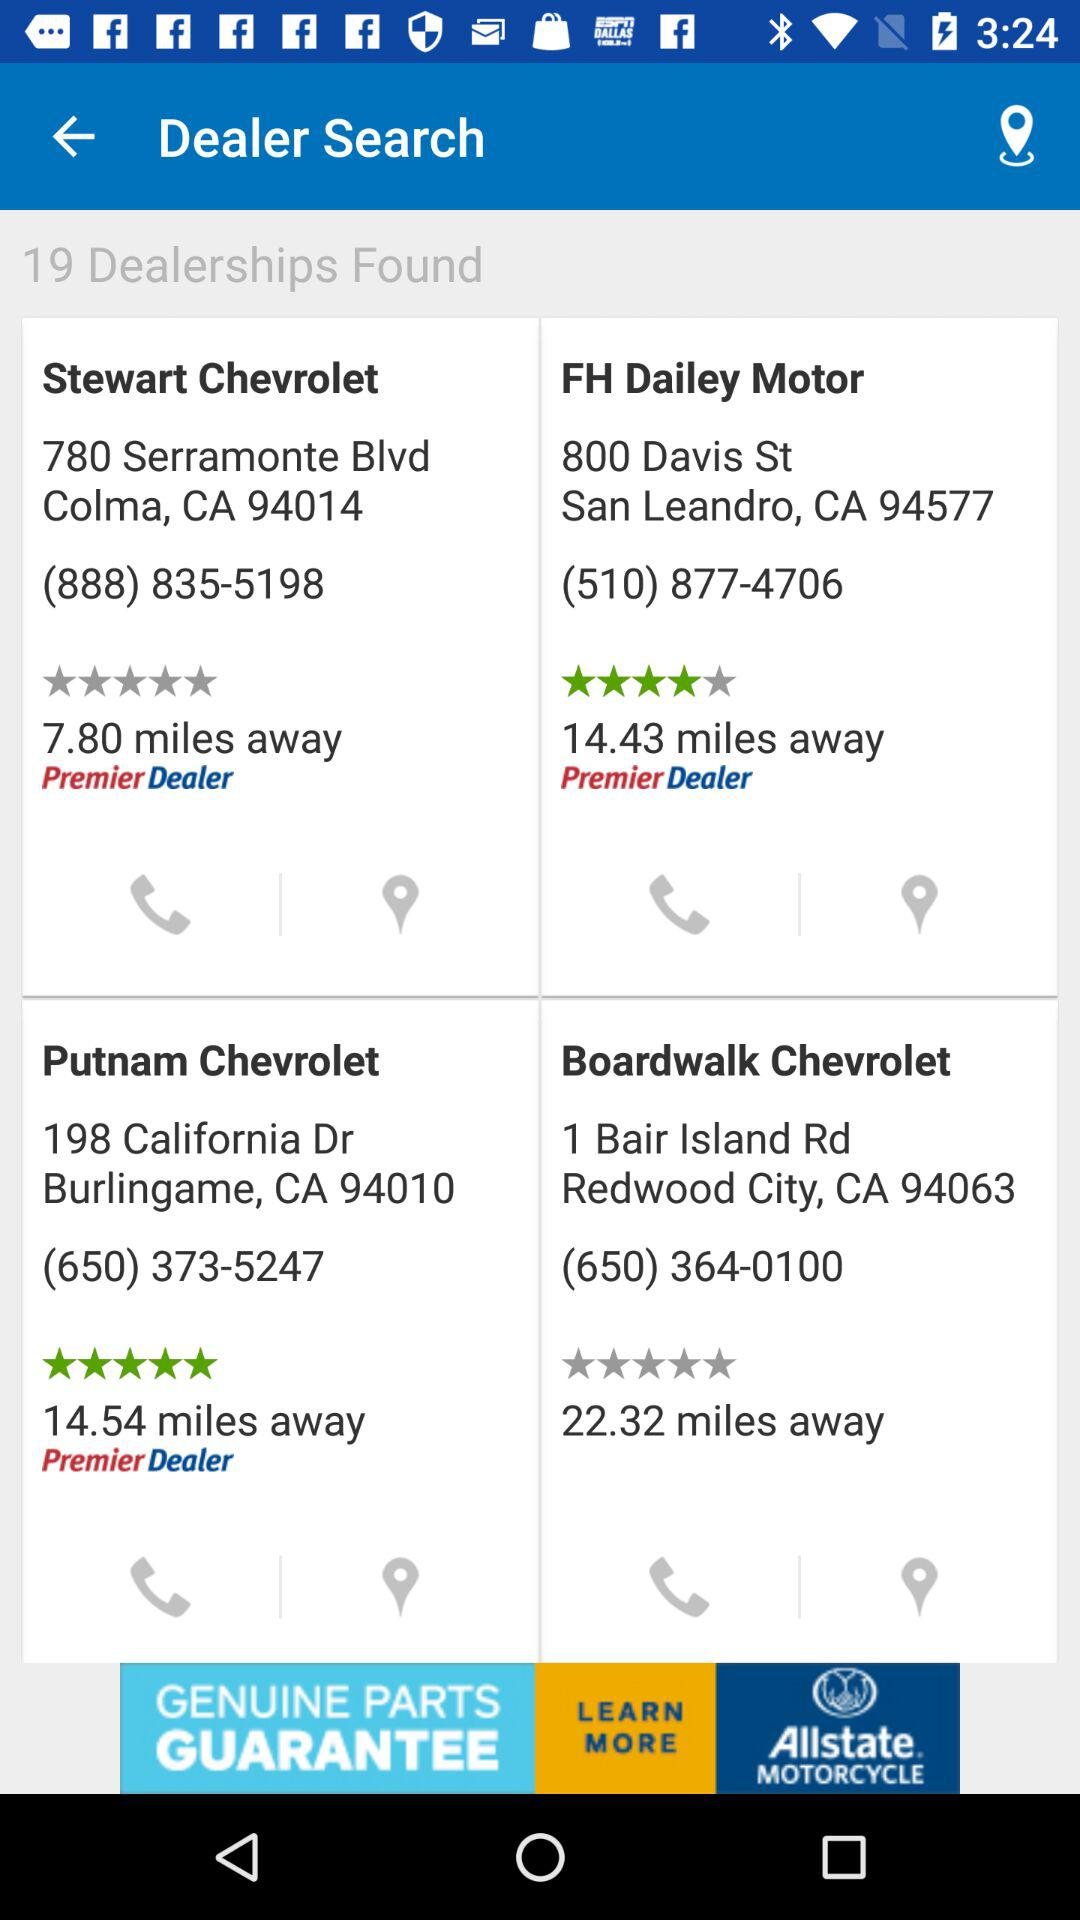What is the address of "Stewart Chevrolet"? The address of "Stewart Chevrolet" is 780 Serramonte Blvd, Colma, CA 94014. 